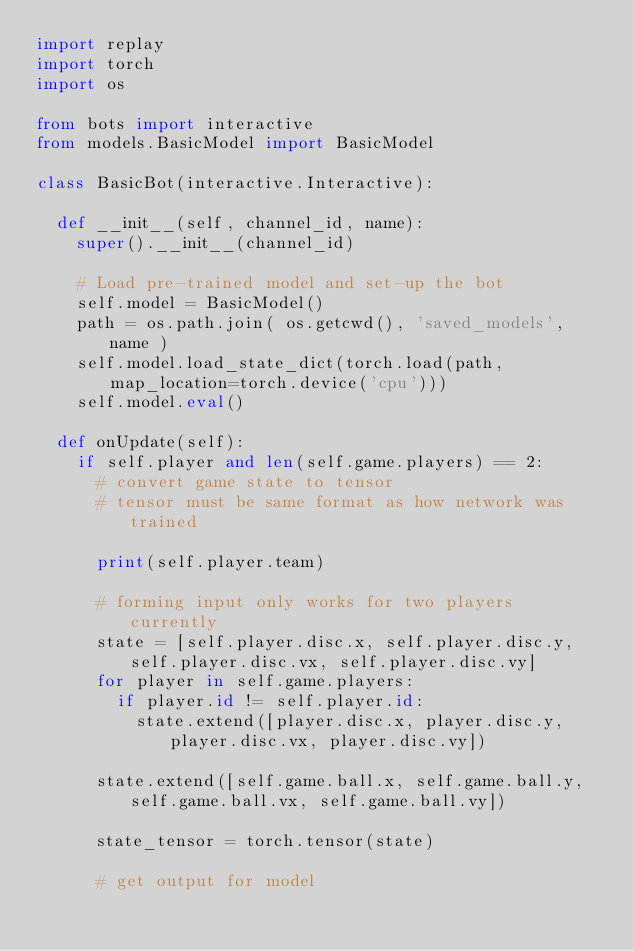Convert code to text. <code><loc_0><loc_0><loc_500><loc_500><_Python_>import replay
import torch
import os

from bots import interactive
from models.BasicModel import BasicModel

class BasicBot(interactive.Interactive):

  def __init__(self, channel_id, name):
    super().__init__(channel_id)

    # Load pre-trained model and set-up the bot
    self.model = BasicModel()
    path = os.path.join( os.getcwd(), 'saved_models', name )
    self.model.load_state_dict(torch.load(path, map_location=torch.device('cpu')))
    self.model.eval()

  def onUpdate(self):
    if self.player and len(self.game.players) == 2:
      # convert game state to tensor
      # tensor must be same format as how network was trained

      print(self.player.team)

      # forming input only works for two players currently
      state = [self.player.disc.x, self.player.disc.y, self.player.disc.vx, self.player.disc.vy]
      for player in self.game.players:
        if player.id != self.player.id:
          state.extend([player.disc.x, player.disc.y, player.disc.vx, player.disc.vy])

      state.extend([self.game.ball.x, self.game.ball.y, self.game.ball.vx, self.game.ball.vy])

      state_tensor = torch.tensor(state)

      # get output for model</code> 